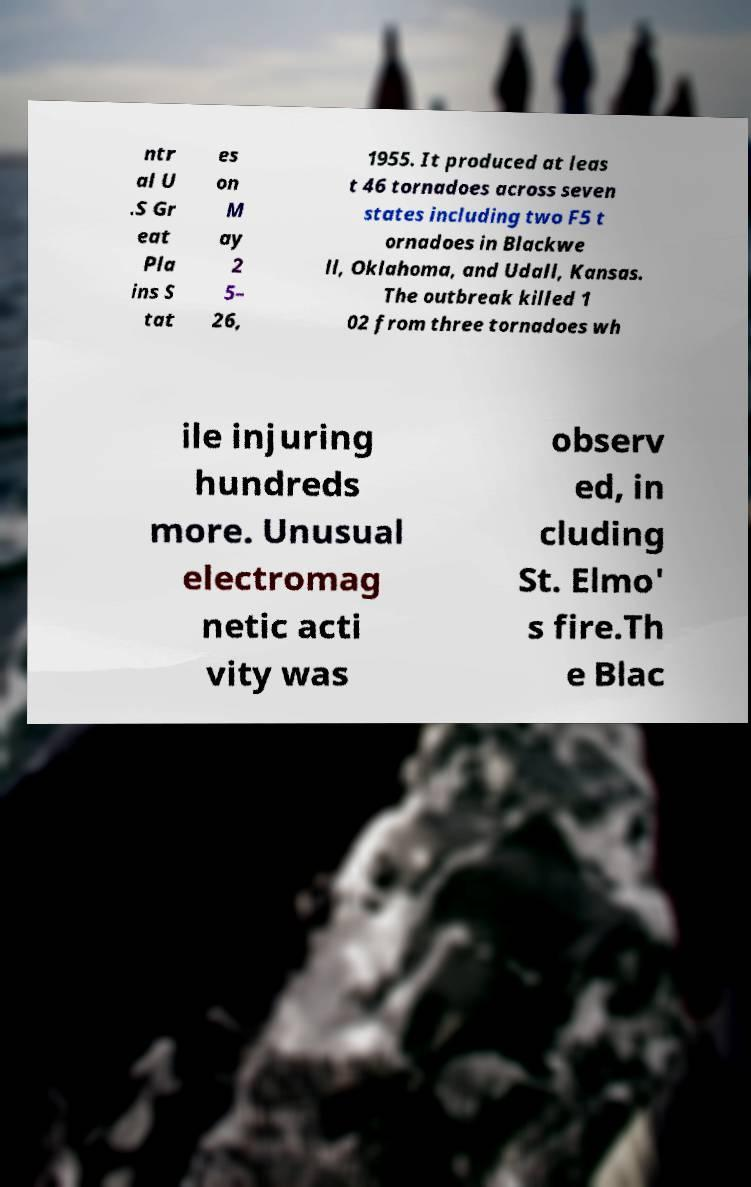Please read and relay the text visible in this image. What does it say? ntr al U .S Gr eat Pla ins S tat es on M ay 2 5– 26, 1955. It produced at leas t 46 tornadoes across seven states including two F5 t ornadoes in Blackwe ll, Oklahoma, and Udall, Kansas. The outbreak killed 1 02 from three tornadoes wh ile injuring hundreds more. Unusual electromag netic acti vity was observ ed, in cluding St. Elmo' s fire.Th e Blac 